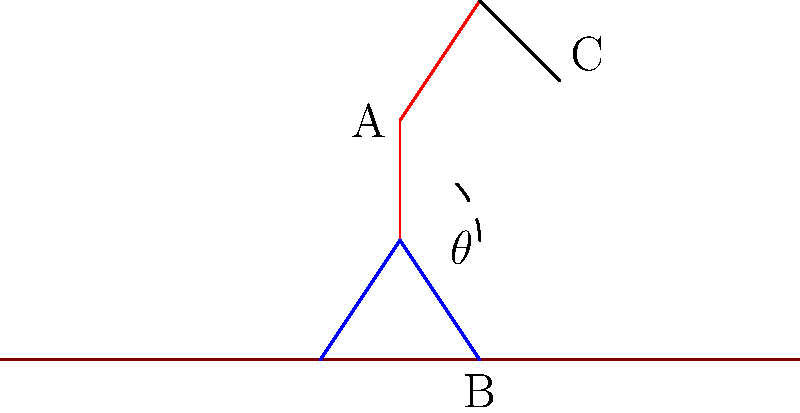In the diagram, an archaeologist is shown in a common excavation posture. If the angle $\theta$ between the thigh and the ground is 45°, and the archaeologist's upper leg (thigh) length is 50 cm, what is the vertical distance (in cm) from the ground to point A (hip joint)? Assume the leg is straight from the knee to the ground. To solve this problem, we need to follow these steps:

1. Recognize that the archaeologist's leg forms a right-angled triangle with the ground.
2. Identify that we're given the angle $\theta = 45°$ and the length of the hypotenuse (thigh) = 50 cm.
3. Recall the trigonometric relationship for sine: $\sin(\theta) = \frac{\text{opposite}}{\text{hypotenuse}}$
4. In this case, we're looking for the opposite side (vertical distance), so we can rearrange the formula:
   $\text{opposite} = \text{hypotenuse} \times \sin(\theta)$
5. Plug in the values:
   $\text{vertical distance} = 50 \text{ cm} \times \sin(45°)$
6. Calculate:
   $\sin(45°) = \frac{\sqrt{2}}{2} \approx 0.7071$
   $\text{vertical distance} = 50 \text{ cm} \times 0.7071 \approx 35.36 \text{ cm}$

Therefore, the vertical distance from the ground to point A (hip joint) is approximately 35.36 cm.
Answer: 35.36 cm 